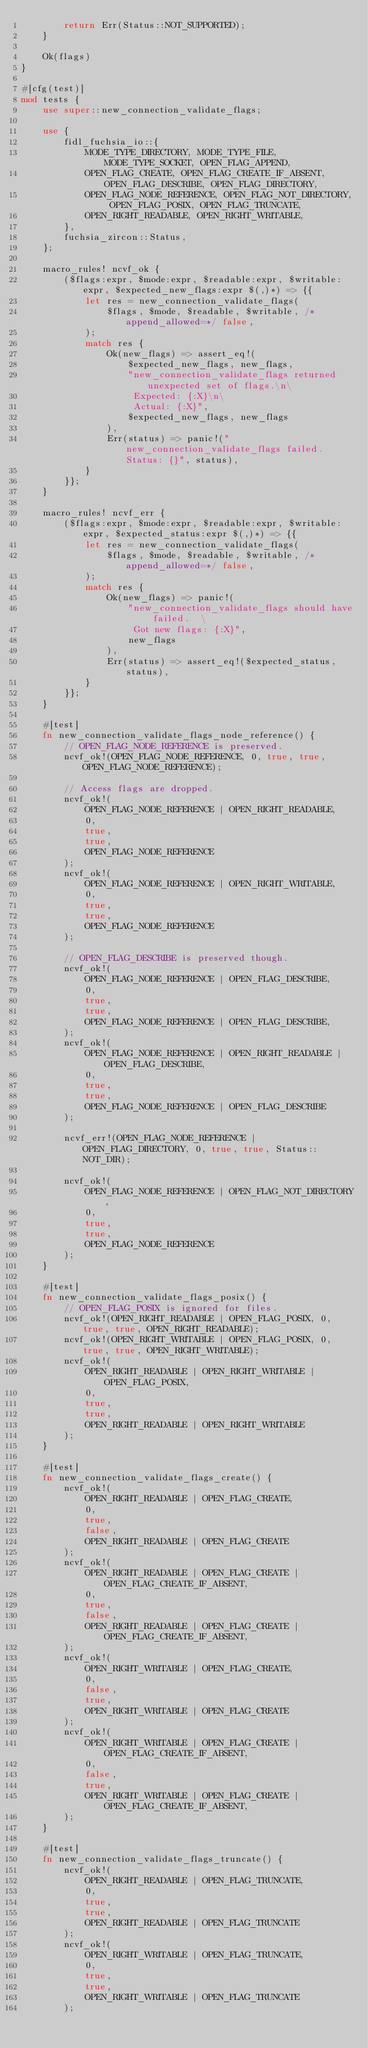Convert code to text. <code><loc_0><loc_0><loc_500><loc_500><_Rust_>        return Err(Status::NOT_SUPPORTED);
    }

    Ok(flags)
}

#[cfg(test)]
mod tests {
    use super::new_connection_validate_flags;

    use {
        fidl_fuchsia_io::{
            MODE_TYPE_DIRECTORY, MODE_TYPE_FILE, MODE_TYPE_SOCKET, OPEN_FLAG_APPEND,
            OPEN_FLAG_CREATE, OPEN_FLAG_CREATE_IF_ABSENT, OPEN_FLAG_DESCRIBE, OPEN_FLAG_DIRECTORY,
            OPEN_FLAG_NODE_REFERENCE, OPEN_FLAG_NOT_DIRECTORY, OPEN_FLAG_POSIX, OPEN_FLAG_TRUNCATE,
            OPEN_RIGHT_READABLE, OPEN_RIGHT_WRITABLE,
        },
        fuchsia_zircon::Status,
    };

    macro_rules! ncvf_ok {
        ($flags:expr, $mode:expr, $readable:expr, $writable:expr, $expected_new_flags:expr $(,)*) => {{
            let res = new_connection_validate_flags(
                $flags, $mode, $readable, $writable, /*append_allowed=*/ false,
            );
            match res {
                Ok(new_flags) => assert_eq!(
                    $expected_new_flags, new_flags,
                    "new_connection_validate_flags returned unexpected set of flags.\n\
                     Expected: {:X}\n\
                     Actual: {:X}",
                    $expected_new_flags, new_flags
                ),
                Err(status) => panic!("new_connection_validate_flags failed.  Status: {}", status),
            }
        }};
    }

    macro_rules! ncvf_err {
        ($flags:expr, $mode:expr, $readable:expr, $writable:expr, $expected_status:expr $(,)*) => {{
            let res = new_connection_validate_flags(
                $flags, $mode, $readable, $writable, /*append_allowed=*/ false,
            );
            match res {
                Ok(new_flags) => panic!(
                    "new_connection_validate_flags should have failed.  \
                     Got new flags: {:X}",
                    new_flags
                ),
                Err(status) => assert_eq!($expected_status, status),
            }
        }};
    }

    #[test]
    fn new_connection_validate_flags_node_reference() {
        // OPEN_FLAG_NODE_REFERENCE is preserved.
        ncvf_ok!(OPEN_FLAG_NODE_REFERENCE, 0, true, true, OPEN_FLAG_NODE_REFERENCE);

        // Access flags are dropped.
        ncvf_ok!(
            OPEN_FLAG_NODE_REFERENCE | OPEN_RIGHT_READABLE,
            0,
            true,
            true,
            OPEN_FLAG_NODE_REFERENCE
        );
        ncvf_ok!(
            OPEN_FLAG_NODE_REFERENCE | OPEN_RIGHT_WRITABLE,
            0,
            true,
            true,
            OPEN_FLAG_NODE_REFERENCE
        );

        // OPEN_FLAG_DESCRIBE is preserved though.
        ncvf_ok!(
            OPEN_FLAG_NODE_REFERENCE | OPEN_FLAG_DESCRIBE,
            0,
            true,
            true,
            OPEN_FLAG_NODE_REFERENCE | OPEN_FLAG_DESCRIBE,
        );
        ncvf_ok!(
            OPEN_FLAG_NODE_REFERENCE | OPEN_RIGHT_READABLE | OPEN_FLAG_DESCRIBE,
            0,
            true,
            true,
            OPEN_FLAG_NODE_REFERENCE | OPEN_FLAG_DESCRIBE
        );

        ncvf_err!(OPEN_FLAG_NODE_REFERENCE | OPEN_FLAG_DIRECTORY, 0, true, true, Status::NOT_DIR);

        ncvf_ok!(
            OPEN_FLAG_NODE_REFERENCE | OPEN_FLAG_NOT_DIRECTORY,
            0,
            true,
            true,
            OPEN_FLAG_NODE_REFERENCE
        );
    }

    #[test]
    fn new_connection_validate_flags_posix() {
        // OPEN_FLAG_POSIX is ignored for files.
        ncvf_ok!(OPEN_RIGHT_READABLE | OPEN_FLAG_POSIX, 0, true, true, OPEN_RIGHT_READABLE);
        ncvf_ok!(OPEN_RIGHT_WRITABLE | OPEN_FLAG_POSIX, 0, true, true, OPEN_RIGHT_WRITABLE);
        ncvf_ok!(
            OPEN_RIGHT_READABLE | OPEN_RIGHT_WRITABLE | OPEN_FLAG_POSIX,
            0,
            true,
            true,
            OPEN_RIGHT_READABLE | OPEN_RIGHT_WRITABLE
        );
    }

    #[test]
    fn new_connection_validate_flags_create() {
        ncvf_ok!(
            OPEN_RIGHT_READABLE | OPEN_FLAG_CREATE,
            0,
            true,
            false,
            OPEN_RIGHT_READABLE | OPEN_FLAG_CREATE
        );
        ncvf_ok!(
            OPEN_RIGHT_READABLE | OPEN_FLAG_CREATE | OPEN_FLAG_CREATE_IF_ABSENT,
            0,
            true,
            false,
            OPEN_RIGHT_READABLE | OPEN_FLAG_CREATE | OPEN_FLAG_CREATE_IF_ABSENT,
        );
        ncvf_ok!(
            OPEN_RIGHT_WRITABLE | OPEN_FLAG_CREATE,
            0,
            false,
            true,
            OPEN_RIGHT_WRITABLE | OPEN_FLAG_CREATE
        );
        ncvf_ok!(
            OPEN_RIGHT_WRITABLE | OPEN_FLAG_CREATE | OPEN_FLAG_CREATE_IF_ABSENT,
            0,
            false,
            true,
            OPEN_RIGHT_WRITABLE | OPEN_FLAG_CREATE | OPEN_FLAG_CREATE_IF_ABSENT,
        );
    }

    #[test]
    fn new_connection_validate_flags_truncate() {
        ncvf_ok!(
            OPEN_RIGHT_READABLE | OPEN_FLAG_TRUNCATE,
            0,
            true,
            true,
            OPEN_RIGHT_READABLE | OPEN_FLAG_TRUNCATE
        );
        ncvf_ok!(
            OPEN_RIGHT_WRITABLE | OPEN_FLAG_TRUNCATE,
            0,
            true,
            true,
            OPEN_RIGHT_WRITABLE | OPEN_FLAG_TRUNCATE
        );</code> 